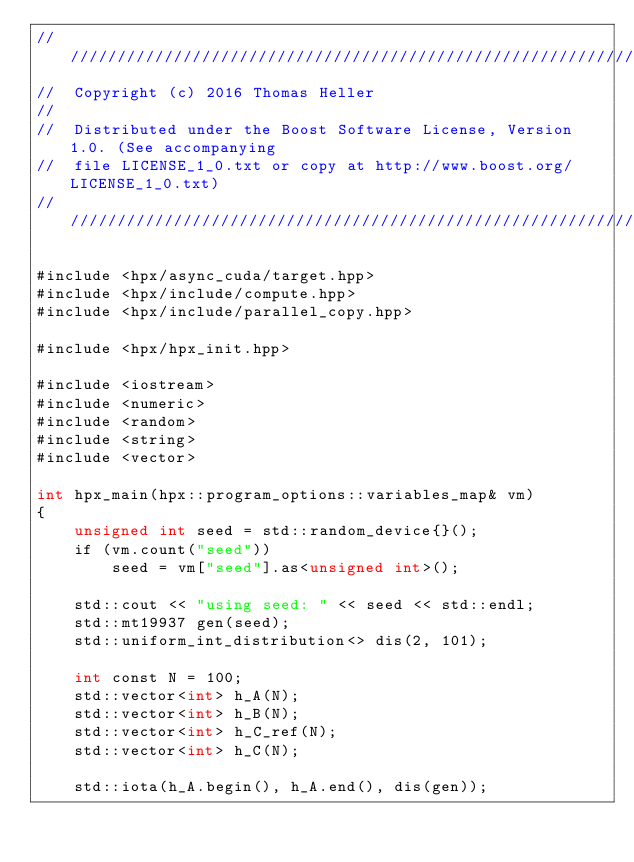Convert code to text. <code><loc_0><loc_0><loc_500><loc_500><_Cuda_>///////////////////////////////////////////////////////////////////////////////
//  Copyright (c) 2016 Thomas Heller
//
//  Distributed under the Boost Software License, Version 1.0. (See accompanying
//  file LICENSE_1_0.txt or copy at http://www.boost.org/LICENSE_1_0.txt)
///////////////////////////////////////////////////////////////////////////////

#include <hpx/async_cuda/target.hpp>
#include <hpx/include/compute.hpp>
#include <hpx/include/parallel_copy.hpp>

#include <hpx/hpx_init.hpp>

#include <iostream>
#include <numeric>
#include <random>
#include <string>
#include <vector>

int hpx_main(hpx::program_options::variables_map& vm)
{
    unsigned int seed = std::random_device{}();
    if (vm.count("seed"))
        seed = vm["seed"].as<unsigned int>();

    std::cout << "using seed: " << seed << std::endl;
    std::mt19937 gen(seed);
    std::uniform_int_distribution<> dis(2, 101);

    int const N = 100;
    std::vector<int> h_A(N);
    std::vector<int> h_B(N);
    std::vector<int> h_C_ref(N);
    std::vector<int> h_C(N);

    std::iota(h_A.begin(), h_A.end(), dis(gen));</code> 